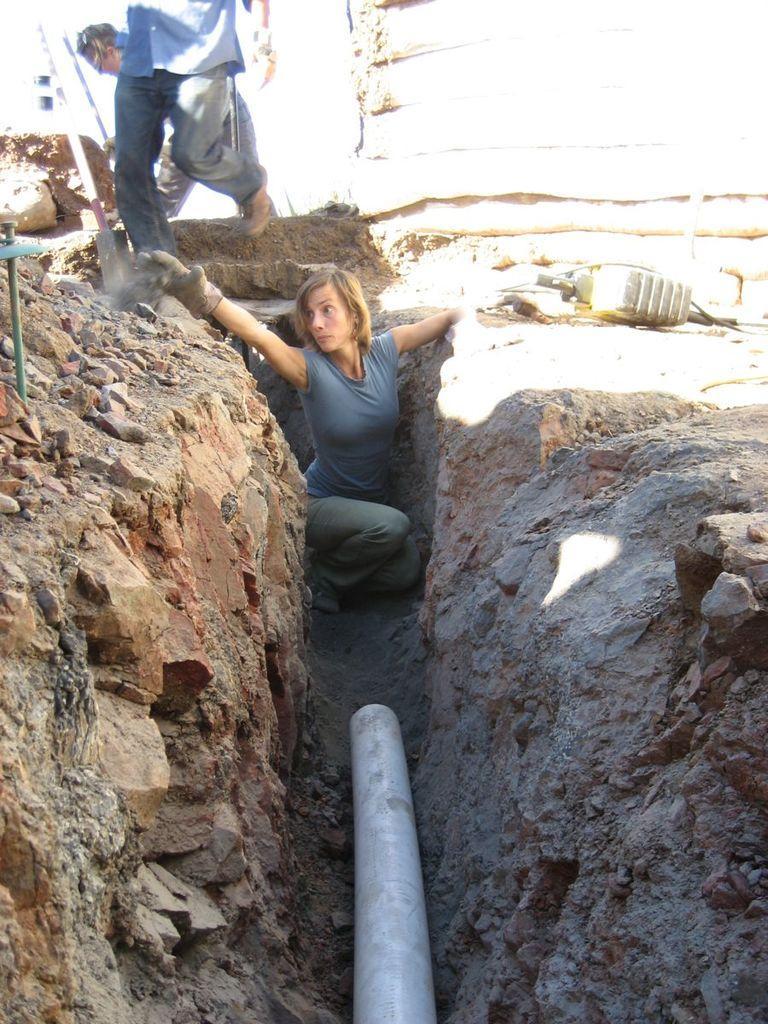Can you describe this image briefly? In this image, we can see people and one of them is wearing gloves and we can see some poles, pipe and there is an object and there are rocks. 